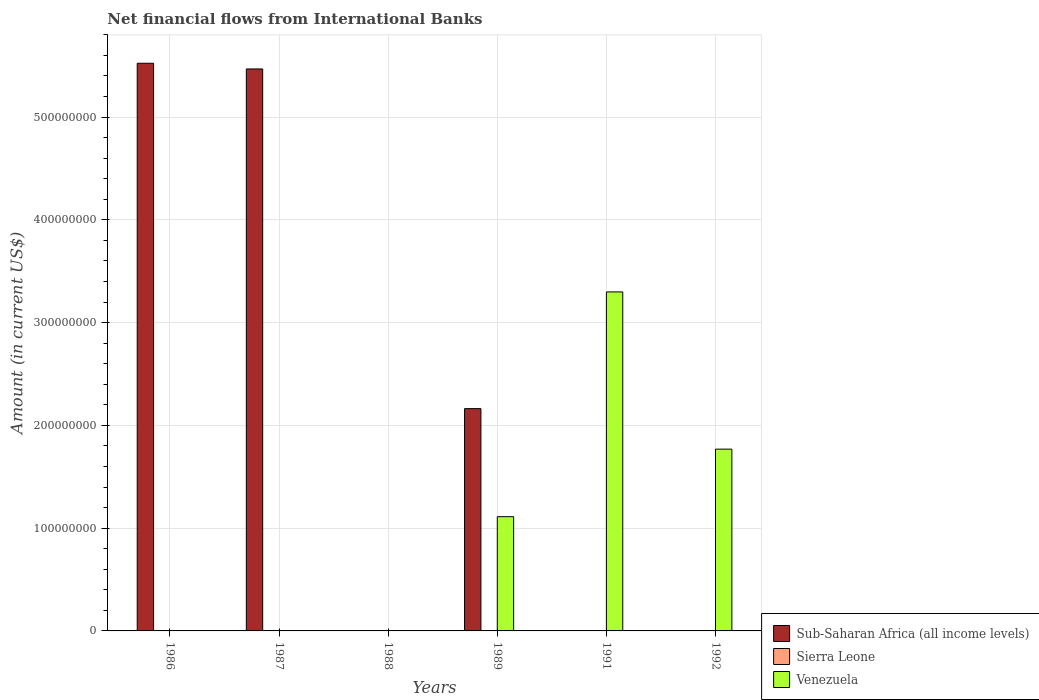How many different coloured bars are there?
Your response must be concise. 2. How many bars are there on the 6th tick from the left?
Make the answer very short. 1. In how many cases, is the number of bars for a given year not equal to the number of legend labels?
Offer a terse response. 6. What is the net financial aid flows in Sub-Saharan Africa (all income levels) in 1987?
Make the answer very short. 5.47e+08. Across all years, what is the maximum net financial aid flows in Venezuela?
Your answer should be compact. 3.30e+08. In which year was the net financial aid flows in Venezuela maximum?
Keep it short and to the point. 1991. What is the total net financial aid flows in Sierra Leone in the graph?
Give a very brief answer. 0. What is the difference between the net financial aid flows in Sub-Saharan Africa (all income levels) in 1986 and that in 1989?
Make the answer very short. 3.36e+08. What is the difference between the net financial aid flows in Sierra Leone in 1992 and the net financial aid flows in Venezuela in 1989?
Ensure brevity in your answer.  -1.11e+08. What is the average net financial aid flows in Sub-Saharan Africa (all income levels) per year?
Ensure brevity in your answer.  2.19e+08. In how many years, is the net financial aid flows in Sierra Leone greater than 100000000 US$?
Your answer should be compact. 0. What is the difference between the highest and the second highest net financial aid flows in Sub-Saharan Africa (all income levels)?
Offer a terse response. 5.53e+06. What is the difference between the highest and the lowest net financial aid flows in Sub-Saharan Africa (all income levels)?
Offer a very short reply. 5.52e+08. In how many years, is the net financial aid flows in Venezuela greater than the average net financial aid flows in Venezuela taken over all years?
Keep it short and to the point. 3. Is it the case that in every year, the sum of the net financial aid flows in Sierra Leone and net financial aid flows in Sub-Saharan Africa (all income levels) is greater than the net financial aid flows in Venezuela?
Give a very brief answer. No. What is the difference between two consecutive major ticks on the Y-axis?
Your answer should be compact. 1.00e+08. Are the values on the major ticks of Y-axis written in scientific E-notation?
Offer a very short reply. No. Does the graph contain any zero values?
Your answer should be compact. Yes. What is the title of the graph?
Make the answer very short. Net financial flows from International Banks. What is the label or title of the Y-axis?
Your answer should be very brief. Amount (in current US$). What is the Amount (in current US$) in Sub-Saharan Africa (all income levels) in 1986?
Make the answer very short. 5.52e+08. What is the Amount (in current US$) in Venezuela in 1986?
Ensure brevity in your answer.  0. What is the Amount (in current US$) of Sub-Saharan Africa (all income levels) in 1987?
Provide a short and direct response. 5.47e+08. What is the Amount (in current US$) of Sierra Leone in 1987?
Offer a very short reply. 0. What is the Amount (in current US$) of Sierra Leone in 1988?
Provide a succinct answer. 0. What is the Amount (in current US$) in Venezuela in 1988?
Ensure brevity in your answer.  0. What is the Amount (in current US$) in Sub-Saharan Africa (all income levels) in 1989?
Ensure brevity in your answer.  2.16e+08. What is the Amount (in current US$) in Venezuela in 1989?
Your response must be concise. 1.11e+08. What is the Amount (in current US$) in Sub-Saharan Africa (all income levels) in 1991?
Keep it short and to the point. 0. What is the Amount (in current US$) of Venezuela in 1991?
Your response must be concise. 3.30e+08. What is the Amount (in current US$) in Venezuela in 1992?
Ensure brevity in your answer.  1.77e+08. Across all years, what is the maximum Amount (in current US$) of Sub-Saharan Africa (all income levels)?
Offer a terse response. 5.52e+08. Across all years, what is the maximum Amount (in current US$) of Venezuela?
Your answer should be compact. 3.30e+08. Across all years, what is the minimum Amount (in current US$) of Sub-Saharan Africa (all income levels)?
Provide a succinct answer. 0. Across all years, what is the minimum Amount (in current US$) in Venezuela?
Make the answer very short. 0. What is the total Amount (in current US$) in Sub-Saharan Africa (all income levels) in the graph?
Offer a very short reply. 1.32e+09. What is the total Amount (in current US$) in Sierra Leone in the graph?
Keep it short and to the point. 0. What is the total Amount (in current US$) of Venezuela in the graph?
Offer a very short reply. 6.18e+08. What is the difference between the Amount (in current US$) of Sub-Saharan Africa (all income levels) in 1986 and that in 1987?
Offer a terse response. 5.53e+06. What is the difference between the Amount (in current US$) of Sub-Saharan Africa (all income levels) in 1986 and that in 1989?
Your answer should be very brief. 3.36e+08. What is the difference between the Amount (in current US$) in Sub-Saharan Africa (all income levels) in 1987 and that in 1989?
Your answer should be compact. 3.31e+08. What is the difference between the Amount (in current US$) in Venezuela in 1989 and that in 1991?
Offer a very short reply. -2.19e+08. What is the difference between the Amount (in current US$) in Venezuela in 1989 and that in 1992?
Give a very brief answer. -6.57e+07. What is the difference between the Amount (in current US$) of Venezuela in 1991 and that in 1992?
Ensure brevity in your answer.  1.53e+08. What is the difference between the Amount (in current US$) in Sub-Saharan Africa (all income levels) in 1986 and the Amount (in current US$) in Venezuela in 1989?
Keep it short and to the point. 4.41e+08. What is the difference between the Amount (in current US$) in Sub-Saharan Africa (all income levels) in 1986 and the Amount (in current US$) in Venezuela in 1991?
Offer a terse response. 2.23e+08. What is the difference between the Amount (in current US$) of Sub-Saharan Africa (all income levels) in 1986 and the Amount (in current US$) of Venezuela in 1992?
Provide a short and direct response. 3.75e+08. What is the difference between the Amount (in current US$) in Sub-Saharan Africa (all income levels) in 1987 and the Amount (in current US$) in Venezuela in 1989?
Give a very brief answer. 4.36e+08. What is the difference between the Amount (in current US$) of Sub-Saharan Africa (all income levels) in 1987 and the Amount (in current US$) of Venezuela in 1991?
Provide a short and direct response. 2.17e+08. What is the difference between the Amount (in current US$) in Sub-Saharan Africa (all income levels) in 1987 and the Amount (in current US$) in Venezuela in 1992?
Keep it short and to the point. 3.70e+08. What is the difference between the Amount (in current US$) in Sub-Saharan Africa (all income levels) in 1989 and the Amount (in current US$) in Venezuela in 1991?
Keep it short and to the point. -1.14e+08. What is the difference between the Amount (in current US$) of Sub-Saharan Africa (all income levels) in 1989 and the Amount (in current US$) of Venezuela in 1992?
Offer a terse response. 3.94e+07. What is the average Amount (in current US$) of Sub-Saharan Africa (all income levels) per year?
Your response must be concise. 2.19e+08. What is the average Amount (in current US$) in Sierra Leone per year?
Provide a succinct answer. 0. What is the average Amount (in current US$) in Venezuela per year?
Your answer should be compact. 1.03e+08. In the year 1989, what is the difference between the Amount (in current US$) in Sub-Saharan Africa (all income levels) and Amount (in current US$) in Venezuela?
Your answer should be very brief. 1.05e+08. What is the ratio of the Amount (in current US$) in Sub-Saharan Africa (all income levels) in 1986 to that in 1989?
Offer a terse response. 2.55. What is the ratio of the Amount (in current US$) of Sub-Saharan Africa (all income levels) in 1987 to that in 1989?
Your answer should be very brief. 2.53. What is the ratio of the Amount (in current US$) in Venezuela in 1989 to that in 1991?
Give a very brief answer. 0.34. What is the ratio of the Amount (in current US$) of Venezuela in 1989 to that in 1992?
Your answer should be compact. 0.63. What is the ratio of the Amount (in current US$) of Venezuela in 1991 to that in 1992?
Your response must be concise. 1.86. What is the difference between the highest and the second highest Amount (in current US$) in Sub-Saharan Africa (all income levels)?
Provide a short and direct response. 5.53e+06. What is the difference between the highest and the second highest Amount (in current US$) in Venezuela?
Your response must be concise. 1.53e+08. What is the difference between the highest and the lowest Amount (in current US$) of Sub-Saharan Africa (all income levels)?
Offer a terse response. 5.52e+08. What is the difference between the highest and the lowest Amount (in current US$) in Venezuela?
Your answer should be very brief. 3.30e+08. 